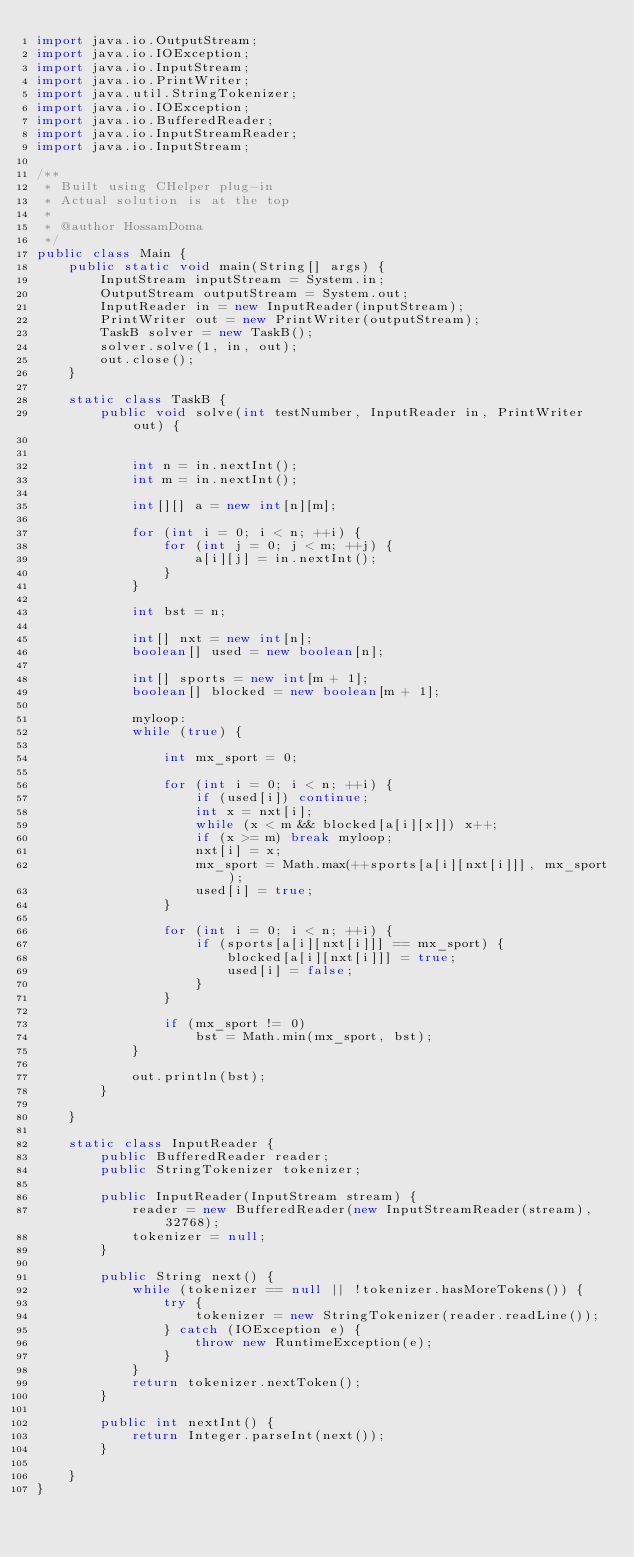<code> <loc_0><loc_0><loc_500><loc_500><_Java_>import java.io.OutputStream;
import java.io.IOException;
import java.io.InputStream;
import java.io.PrintWriter;
import java.util.StringTokenizer;
import java.io.IOException;
import java.io.BufferedReader;
import java.io.InputStreamReader;
import java.io.InputStream;

/**
 * Built using CHelper plug-in
 * Actual solution is at the top
 *
 * @author HossamDoma
 */
public class Main {
    public static void main(String[] args) {
        InputStream inputStream = System.in;
        OutputStream outputStream = System.out;
        InputReader in = new InputReader(inputStream);
        PrintWriter out = new PrintWriter(outputStream);
        TaskB solver = new TaskB();
        solver.solve(1, in, out);
        out.close();
    }

    static class TaskB {
        public void solve(int testNumber, InputReader in, PrintWriter out) {


            int n = in.nextInt();
            int m = in.nextInt();

            int[][] a = new int[n][m];

            for (int i = 0; i < n; ++i) {
                for (int j = 0; j < m; ++j) {
                    a[i][j] = in.nextInt();
                }
            }

            int bst = n;

            int[] nxt = new int[n];
            boolean[] used = new boolean[n];

            int[] sports = new int[m + 1];
            boolean[] blocked = new boolean[m + 1];

            myloop:
            while (true) {

                int mx_sport = 0;

                for (int i = 0; i < n; ++i) {
                    if (used[i]) continue;
                    int x = nxt[i];
                    while (x < m && blocked[a[i][x]]) x++;
                    if (x >= m) break myloop;
                    nxt[i] = x;
                    mx_sport = Math.max(++sports[a[i][nxt[i]]], mx_sport);
                    used[i] = true;
                }

                for (int i = 0; i < n; ++i) {
                    if (sports[a[i][nxt[i]]] == mx_sport) {
                        blocked[a[i][nxt[i]]] = true;
                        used[i] = false;
                    }
                }

                if (mx_sport != 0)
                    bst = Math.min(mx_sport, bst);
            }

            out.println(bst);
        }

    }

    static class InputReader {
        public BufferedReader reader;
        public StringTokenizer tokenizer;

        public InputReader(InputStream stream) {
            reader = new BufferedReader(new InputStreamReader(stream), 32768);
            tokenizer = null;
        }

        public String next() {
            while (tokenizer == null || !tokenizer.hasMoreTokens()) {
                try {
                    tokenizer = new StringTokenizer(reader.readLine());
                } catch (IOException e) {
                    throw new RuntimeException(e);
                }
            }
            return tokenizer.nextToken();
        }

        public int nextInt() {
            return Integer.parseInt(next());
        }

    }
}

</code> 